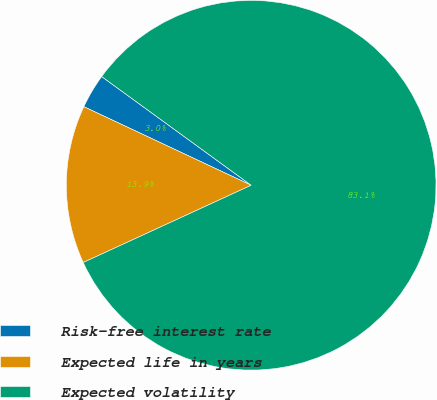Convert chart to OTSL. <chart><loc_0><loc_0><loc_500><loc_500><pie_chart><fcel>Risk-free interest rate<fcel>Expected life in years<fcel>Expected volatility<nl><fcel>3.02%<fcel>13.85%<fcel>83.13%<nl></chart> 